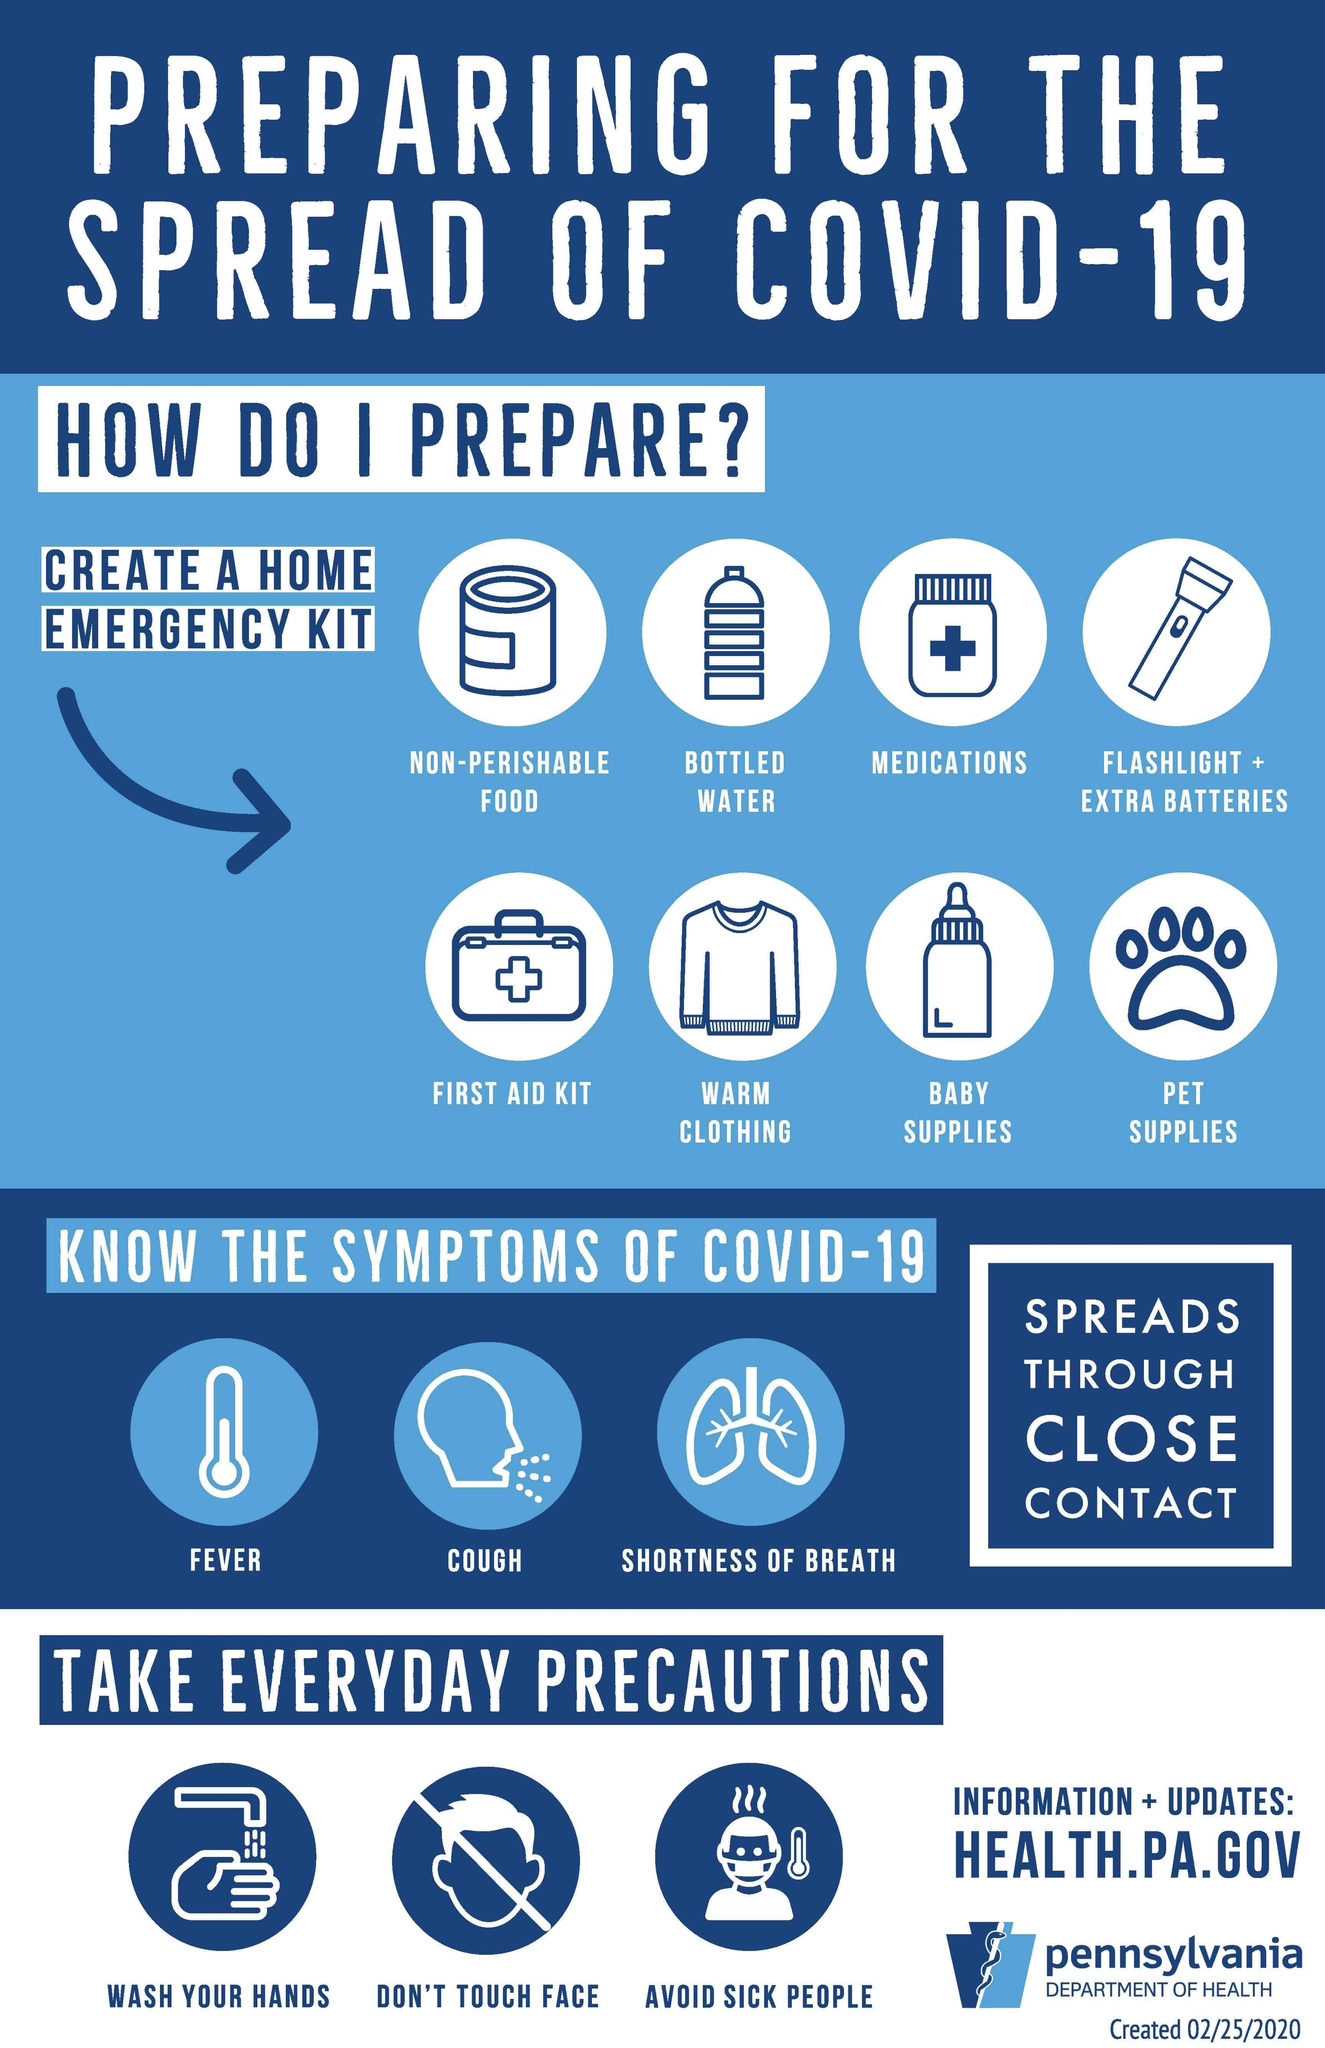What are the symptoms of COVID-19 other than fever & shortness of breath?
Answer the question with a short phrase. COUGH What are the precautionary measures to be taken other than avoiding the sick people inorder to prevent the spread of coronavirus? WASH YOUR HANDS, DON'T TOUCH FACE 